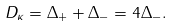<formula> <loc_0><loc_0><loc_500><loc_500>D _ { \kappa } = \Delta _ { + } + \Delta _ { - } = 4 \Delta _ { - } .</formula> 